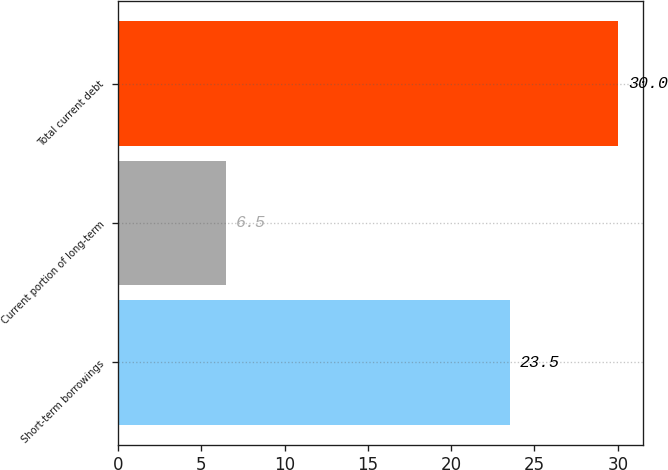Convert chart. <chart><loc_0><loc_0><loc_500><loc_500><bar_chart><fcel>Short-term borrowings<fcel>Current portion of long-term<fcel>Total current debt<nl><fcel>23.5<fcel>6.5<fcel>30<nl></chart> 